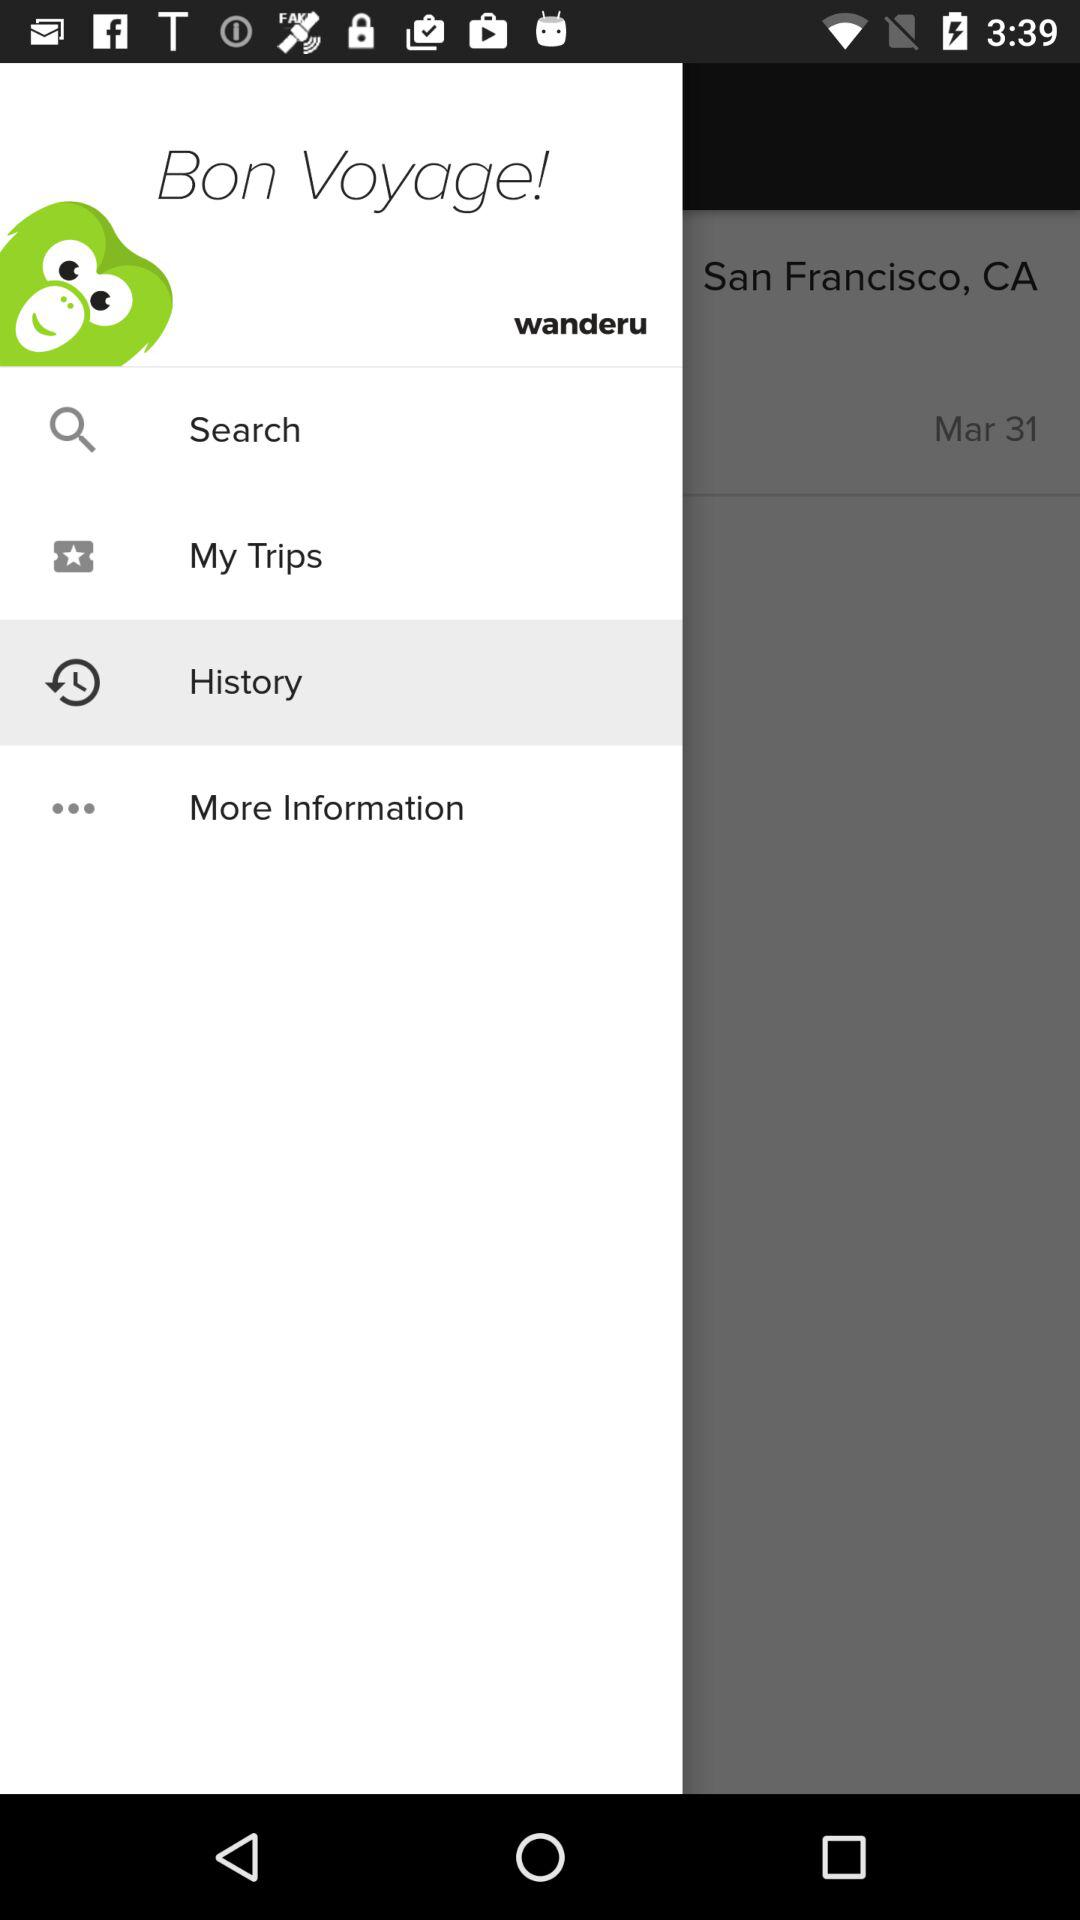Which item is selected in the menu? The item "History" is selected in the menu. 